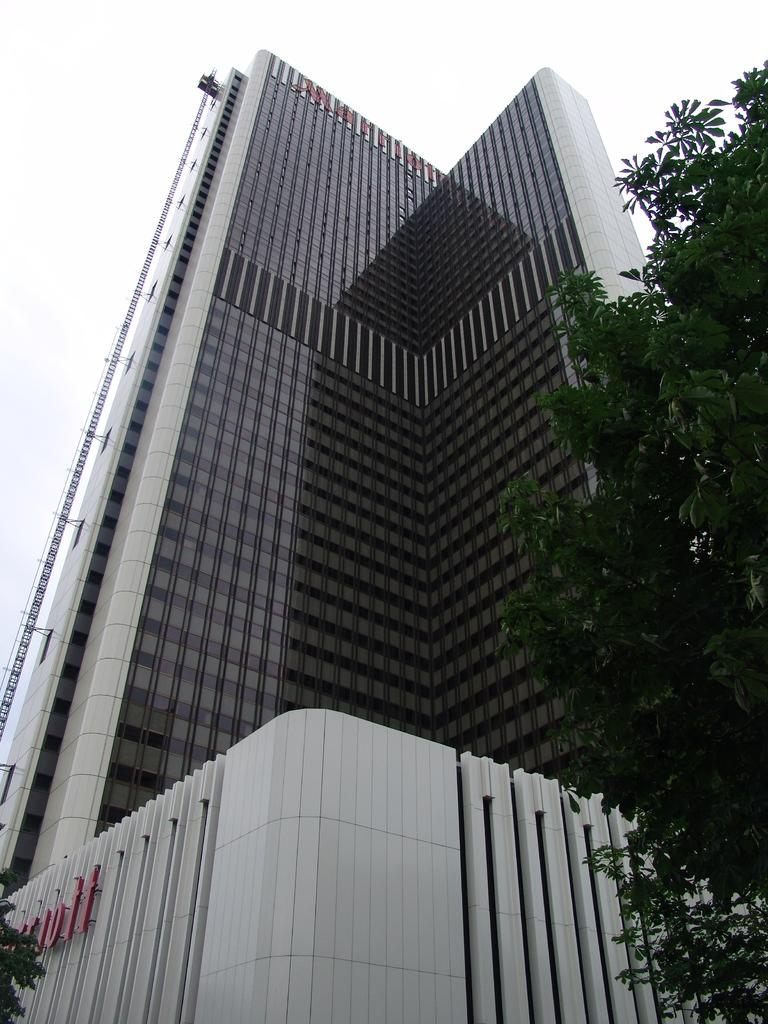What type of vegetation can be seen in the image? There are leaves in the image. What type of structure is present in the image? There is a building in the image. What can be seen in the background of the image? The sky is visible in the background of the image. Can you tell me how many giraffes are visible in the image? There are no giraffes present in the image. What type of nut is being used as a decoration on the building in the image? There is no nut being used as a decoration on the building in the image. 